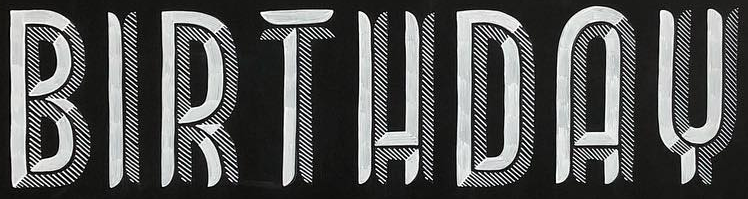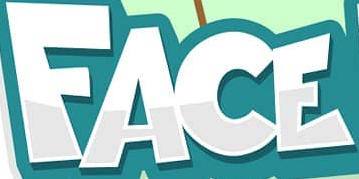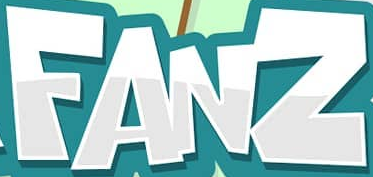What words can you see in these images in sequence, separated by a semicolon? BIRTHDAY; FACE; FANZ 